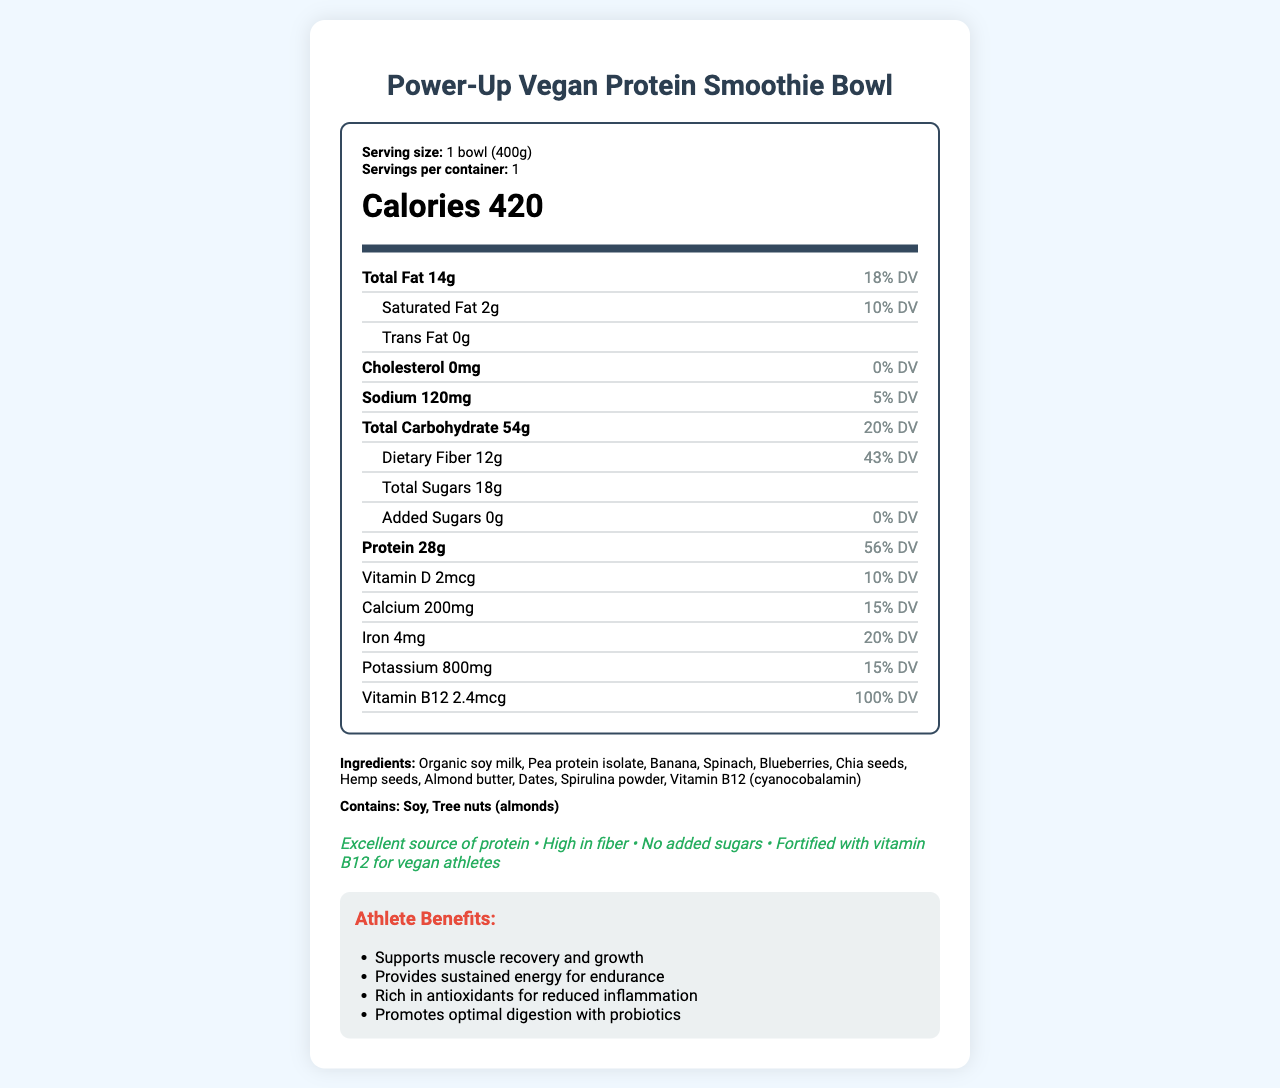What is the serving size of the "Power-Up Vegan Protein Smoothie Bowl"? The serving size is directly stated in the "serving info" section of the document.
Answer: 1 bowl (400g) How many calories are in a serving of the smoothie bowl? The calories are prominently displayed in the "calories" section of the document.
Answer: 420 calories What is the total fat content per serving? The total fat content is displayed in the "Total Fat" row of the nutrient breakdown section.
Answer: 14g What is the amount of dietary fiber in the smoothie bowl? The dietary fiber amount can be found in the "Dietary Fiber" sub-section under "Total Carbohydrate".
Answer: 12g What ingredients are included in the smoothie bowl? The ingredients are listed in the "ingredients" section of the document.
Answer: Organic soy milk, Pea protein isolate, Banana, Spinach, Blueberries, Chia seeds, Hemp seeds, Almond butter, Dates, Spirulina powder, Vitamin B12 (cyanocobalamin) How much Vitamin B12 is in a serving? The amount of Vitamin B12 is shown in the "Vitamin B12" row of the nutrient breakdown.
Answer: 2.4mcg Does the smoothie bowl contain any allergens? Under the "allergens" section, it clearly states that it contains soy and tree nuts (almonds).
Answer: Yes Which of the following is NOT a health claim made by the smoothie bowl? A. Excellent source of protein B. High in fiber C. Contains added sugars D. Fortified with vitamin B12 for vegan athletes The health claim of "Contains added sugars" is not made. The bowl is marketed as having "No added sugars".
Answer: C. Contains added sugars What percentage of the smoothie bowl's calories come from protein? A. 22% B. 27% C. 51% The macronutrient breakdown section specifies 27% of calories come from protein.
Answer: B. 27% True or False: The smoothie bowl is high in potassium. The document states that the smoothie bowl contains 800mg of potassium, which is 15% of the daily value, indicating it is high in potassium.
Answer: True Summarize the main benefits of the Power-Up Vegan Protein Smoothie Bowl for athletes. The "athlete benefits" section outlines these specific benefits, emphasizing why the product is suitable for athletes.
Answer: The smoothie bowl supports muscle recovery and growth, provides sustained energy for endurance, is rich in antioxidants for reducing inflammation, and promotes optimal digestion with probiotics. How much sugar is added to the smoothie bowl? There is no explicit information about the amount of sugar added to the smoothie bowl, only the statement that there are no added sugars.
Answer: Not enough information 